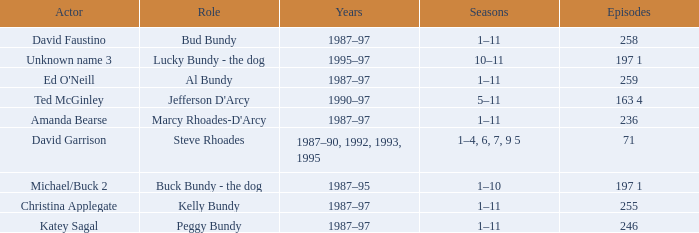How many years did the role of Steve Rhoades last? 1987–90, 1992, 1993, 1995. Could you help me parse every detail presented in this table? {'header': ['Actor', 'Role', 'Years', 'Seasons', 'Episodes'], 'rows': [['David Faustino', 'Bud Bundy', '1987–97', '1–11', '258'], ['Unknown name 3', 'Lucky Bundy - the dog', '1995–97', '10–11', '197 1'], ["Ed O'Neill", 'Al Bundy', '1987–97', '1–11', '259'], ['Ted McGinley', "Jefferson D'Arcy", '1990–97', '5–11', '163 4'], ['Amanda Bearse', "Marcy Rhoades-D'Arcy", '1987–97', '1–11', '236'], ['David Garrison', 'Steve Rhoades', '1987–90, 1992, 1993, 1995', '1–4, 6, 7, 9 5', '71'], ['Michael/Buck 2', 'Buck Bundy - the dog', '1987–95', '1–10', '197 1'], ['Christina Applegate', 'Kelly Bundy', '1987–97', '1–11', '255'], ['Katey Sagal', 'Peggy Bundy', '1987–97', '1–11', '246']]} 